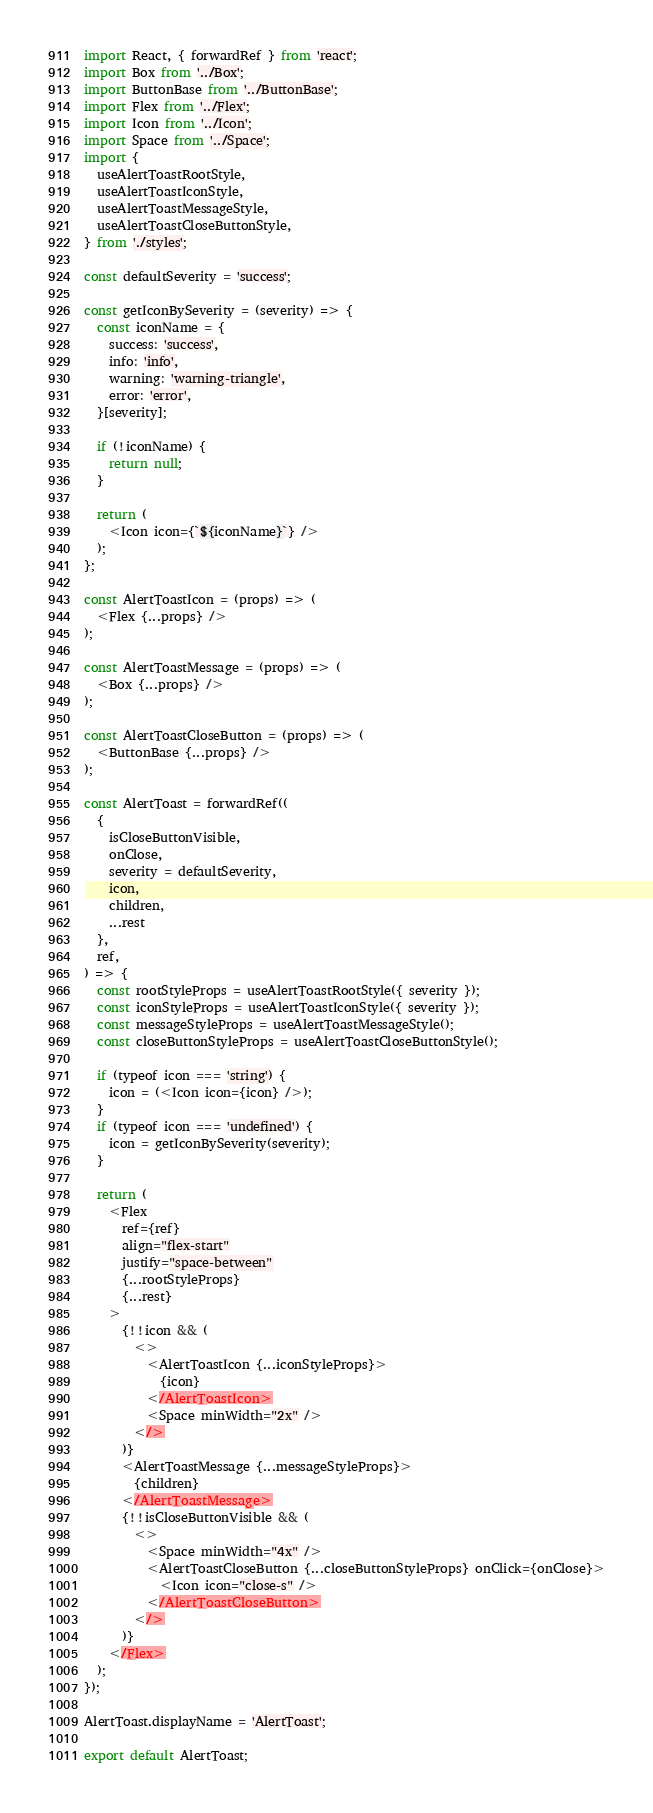<code> <loc_0><loc_0><loc_500><loc_500><_JavaScript_>import React, { forwardRef } from 'react';
import Box from '../Box';
import ButtonBase from '../ButtonBase';
import Flex from '../Flex';
import Icon from '../Icon';
import Space from '../Space';
import {
  useAlertToastRootStyle,
  useAlertToastIconStyle,
  useAlertToastMessageStyle,
  useAlertToastCloseButtonStyle,
} from './styles';

const defaultSeverity = 'success';

const getIconBySeverity = (severity) => {
  const iconName = {
    success: 'success',
    info: 'info',
    warning: 'warning-triangle',
    error: 'error',
  }[severity];

  if (!iconName) {
    return null;
  }

  return (
    <Icon icon={`${iconName}`} />
  );
};

const AlertToastIcon = (props) => (
  <Flex {...props} />
);

const AlertToastMessage = (props) => (
  <Box {...props} />
);

const AlertToastCloseButton = (props) => (
  <ButtonBase {...props} />
);

const AlertToast = forwardRef((
  {
    isCloseButtonVisible,
    onClose,
    severity = defaultSeverity,
    icon,
    children,
    ...rest
  },
  ref,
) => {
  const rootStyleProps = useAlertToastRootStyle({ severity });
  const iconStyleProps = useAlertToastIconStyle({ severity });
  const messageStyleProps = useAlertToastMessageStyle();
  const closeButtonStyleProps = useAlertToastCloseButtonStyle();

  if (typeof icon === 'string') {
    icon = (<Icon icon={icon} />);
  }
  if (typeof icon === 'undefined') {
    icon = getIconBySeverity(severity);
  }

  return (
    <Flex
      ref={ref}
      align="flex-start"
      justify="space-between"
      {...rootStyleProps}
      {...rest}
    >
      {!!icon && (
        <>
          <AlertToastIcon {...iconStyleProps}>
            {icon}
          </AlertToastIcon>
          <Space minWidth="2x" />
        </>
      )}
      <AlertToastMessage {...messageStyleProps}>
        {children}
      </AlertToastMessage>
      {!!isCloseButtonVisible && (
        <>
          <Space minWidth="4x" />
          <AlertToastCloseButton {...closeButtonStyleProps} onClick={onClose}>
            <Icon icon="close-s" />
          </AlertToastCloseButton>
        </>
      )}
    </Flex>
  );
});

AlertToast.displayName = 'AlertToast';

export default AlertToast;
</code> 